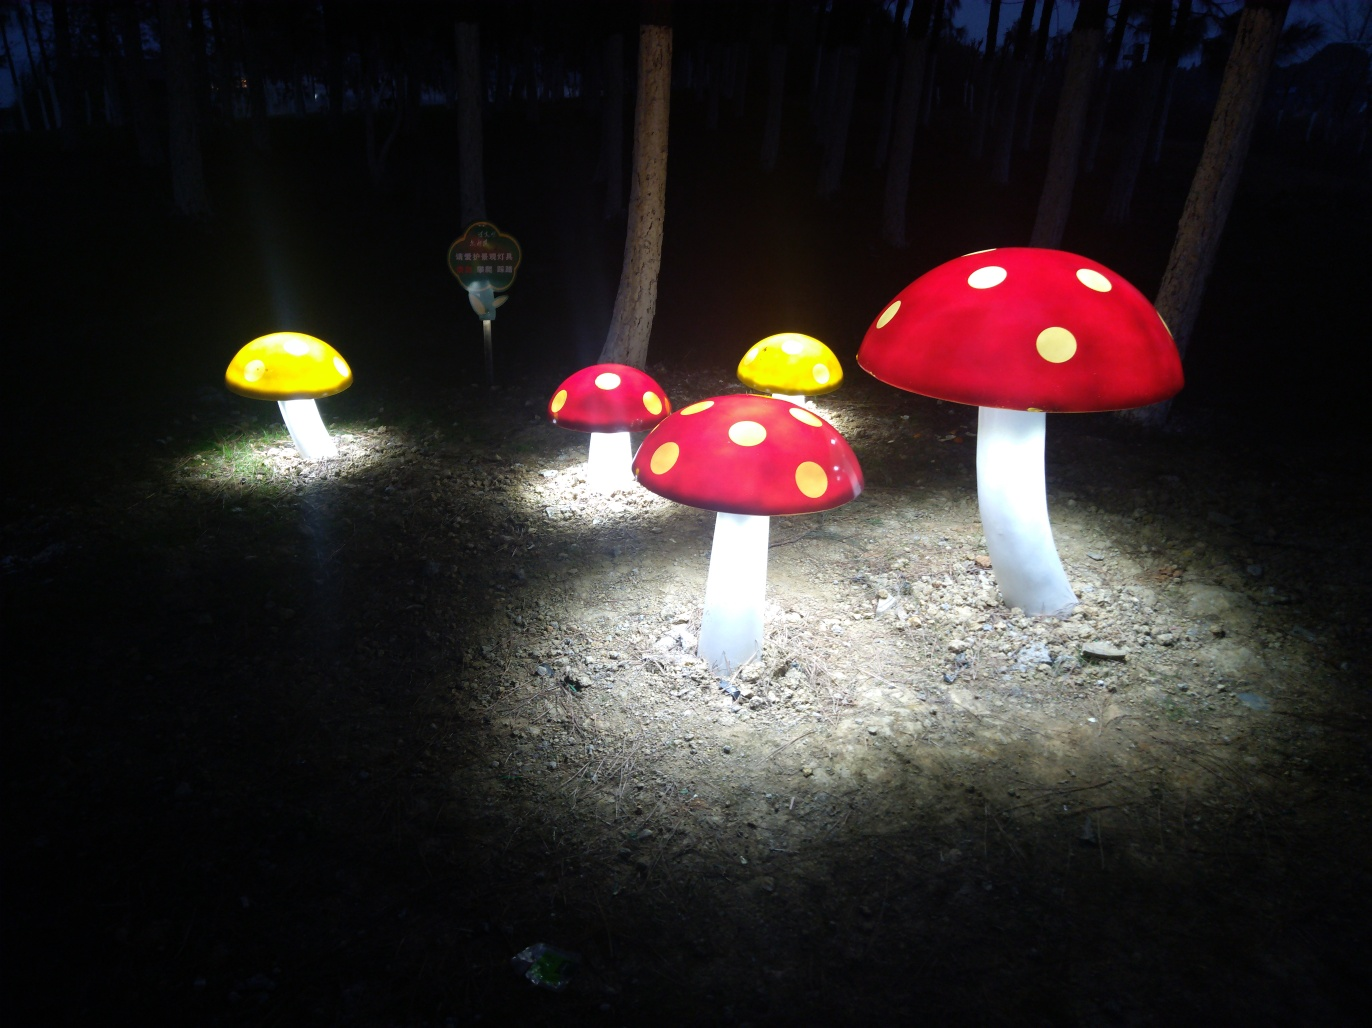Are the mushrooms the only light source in this image? In the image, the mushrooms seem to be the primary light sources, casting a glow on their immediate surroundings. However, there is a subtle ambient light in the background that hints at additional lighting beyond the frame. 